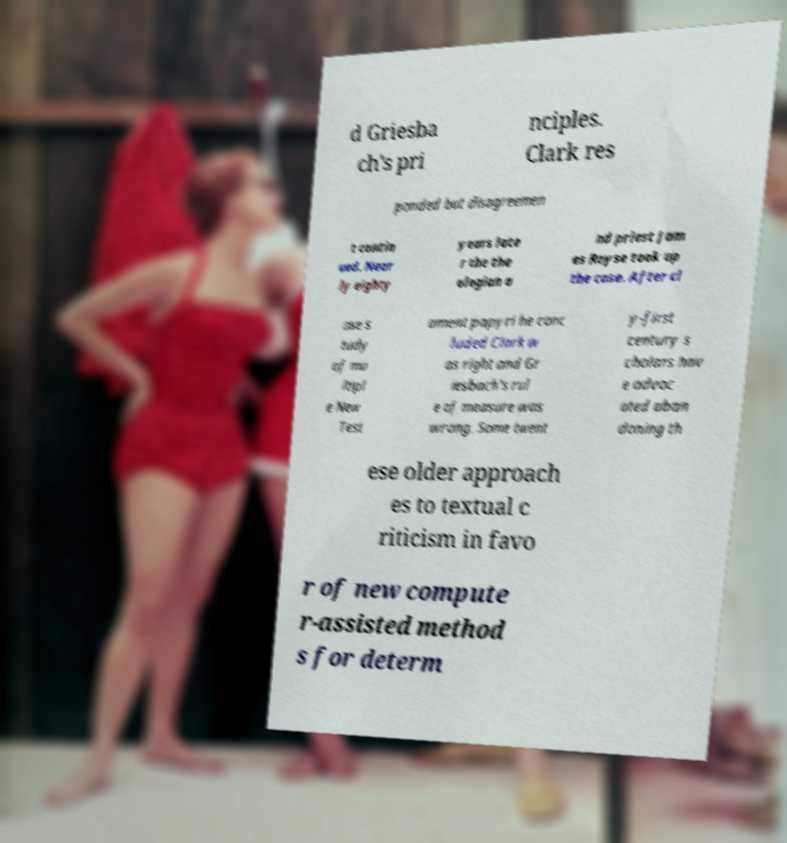Could you assist in decoding the text presented in this image and type it out clearly? d Griesba ch's pri nciples. Clark res ponded but disagreemen t contin ued. Near ly eighty years late r the the ologian a nd priest Jam es Royse took up the case. After cl ose s tudy of mu ltipl e New Test ament papyri he conc luded Clark w as right and Gr iesbach's rul e of measure was wrong. Some twent y-first century s cholars hav e advoc ated aban doning th ese older approach es to textual c riticism in favo r of new compute r-assisted method s for determ 